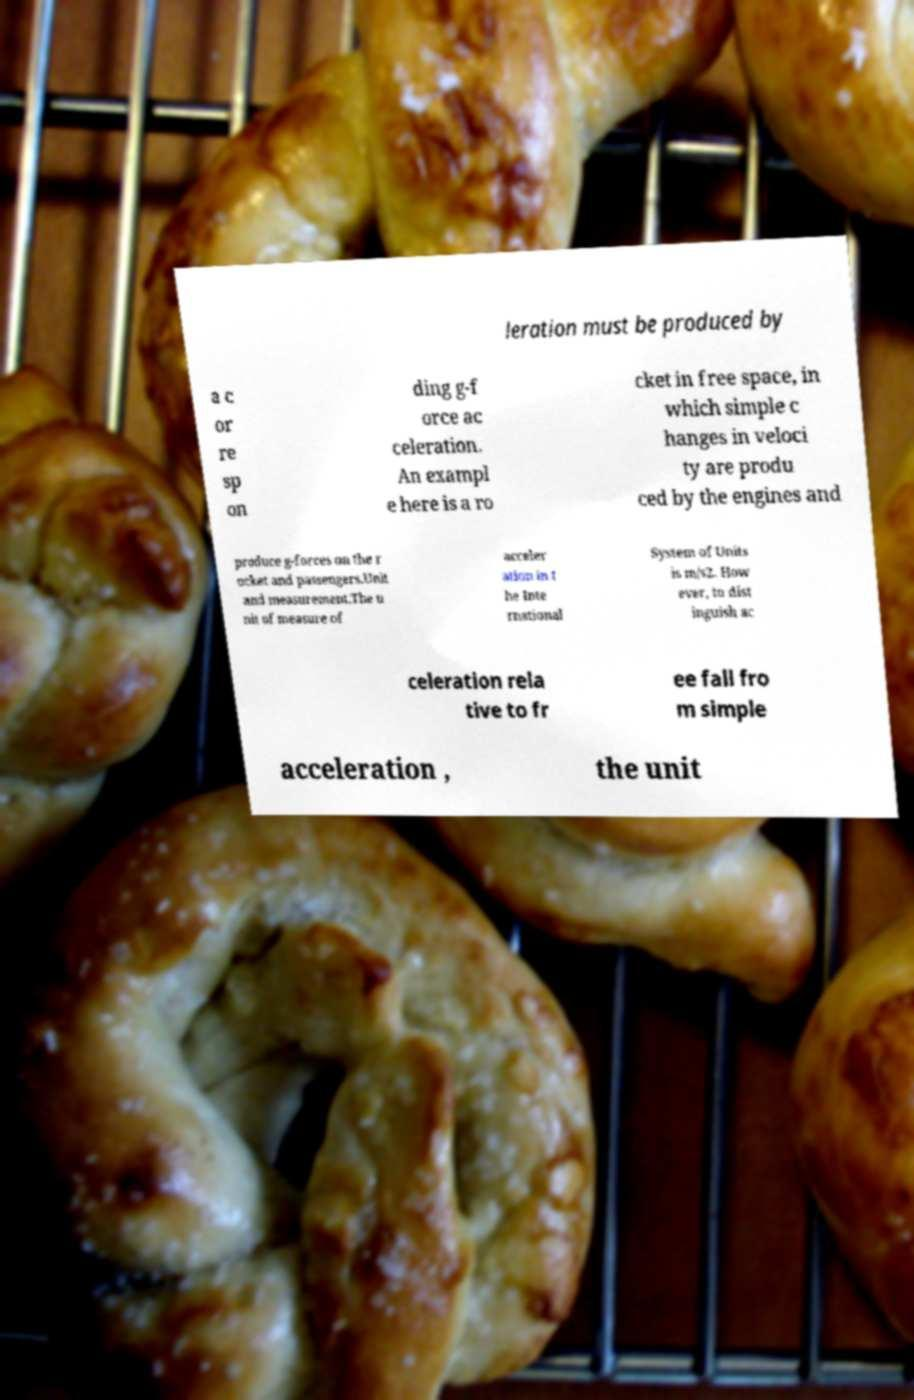There's text embedded in this image that I need extracted. Can you transcribe it verbatim? leration must be produced by a c or re sp on ding g-f orce ac celeration. An exampl e here is a ro cket in free space, in which simple c hanges in veloci ty are produ ced by the engines and produce g-forces on the r ocket and passengers.Unit and measurement.The u nit of measure of acceler ation in t he Inte rnational System of Units is m/s2. How ever, to dist inguish ac celeration rela tive to fr ee fall fro m simple acceleration , the unit 